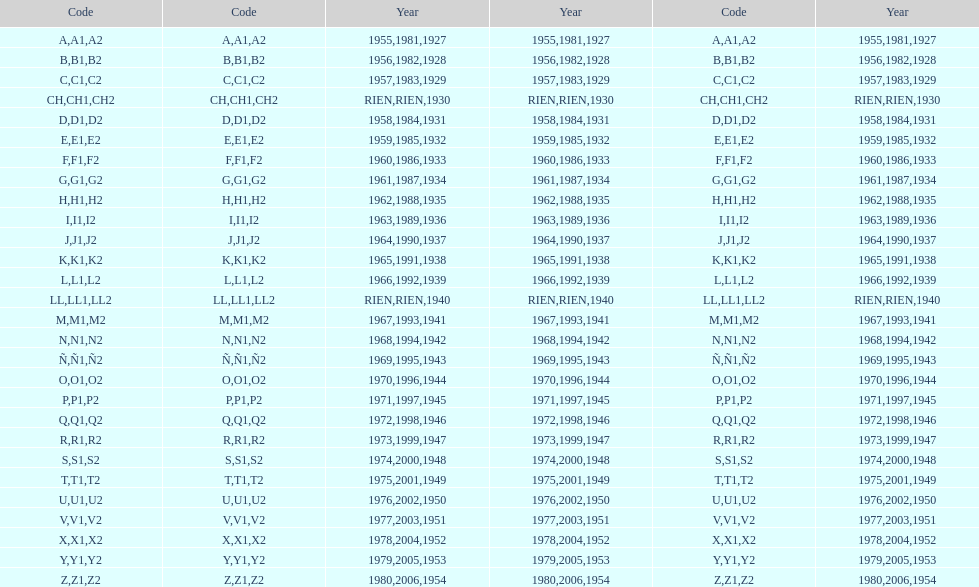List each code not associated to a year. CH1, CH2, LL1, LL2. 